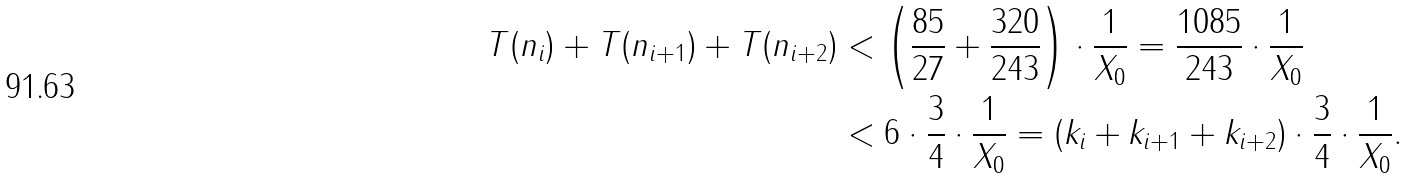Convert formula to latex. <formula><loc_0><loc_0><loc_500><loc_500>T ( n _ { i } ) + T ( n _ { i + 1 } ) + T ( n _ { i + 2 } ) & < \left ( \frac { 8 5 } { 2 7 } + \frac { 3 2 0 } { 2 4 3 } \right ) \cdot \frac { 1 } { X _ { 0 } } = \frac { 1 0 8 5 } { 2 4 3 } \cdot \frac { 1 } { X _ { 0 } } \\ & < 6 \cdot \frac { 3 } { 4 } \cdot \frac { 1 } { X _ { 0 } } = ( k _ { i } + k _ { i + 1 } + k _ { i + 2 } ) \cdot \frac { 3 } { 4 } \cdot \frac { 1 } { X _ { 0 } } .</formula> 